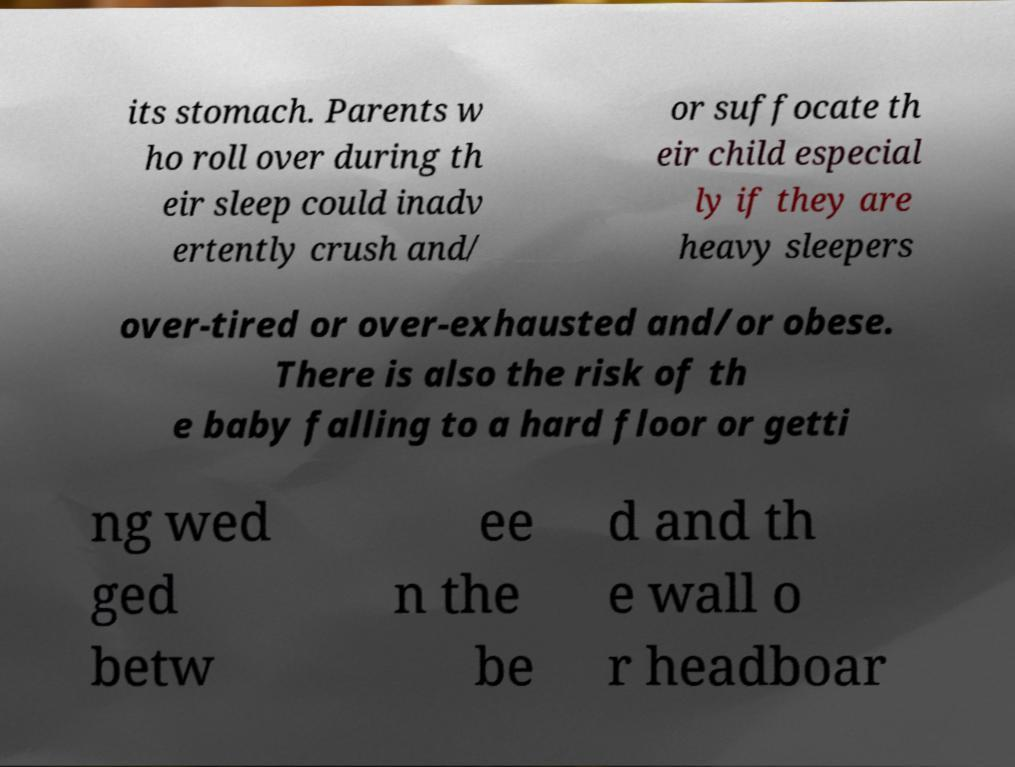Please read and relay the text visible in this image. What does it say? its stomach. Parents w ho roll over during th eir sleep could inadv ertently crush and/ or suffocate th eir child especial ly if they are heavy sleepers over-tired or over-exhausted and/or obese. There is also the risk of th e baby falling to a hard floor or getti ng wed ged betw ee n the be d and th e wall o r headboar 